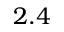<formula> <loc_0><loc_0><loc_500><loc_500>2 . 4</formula> 